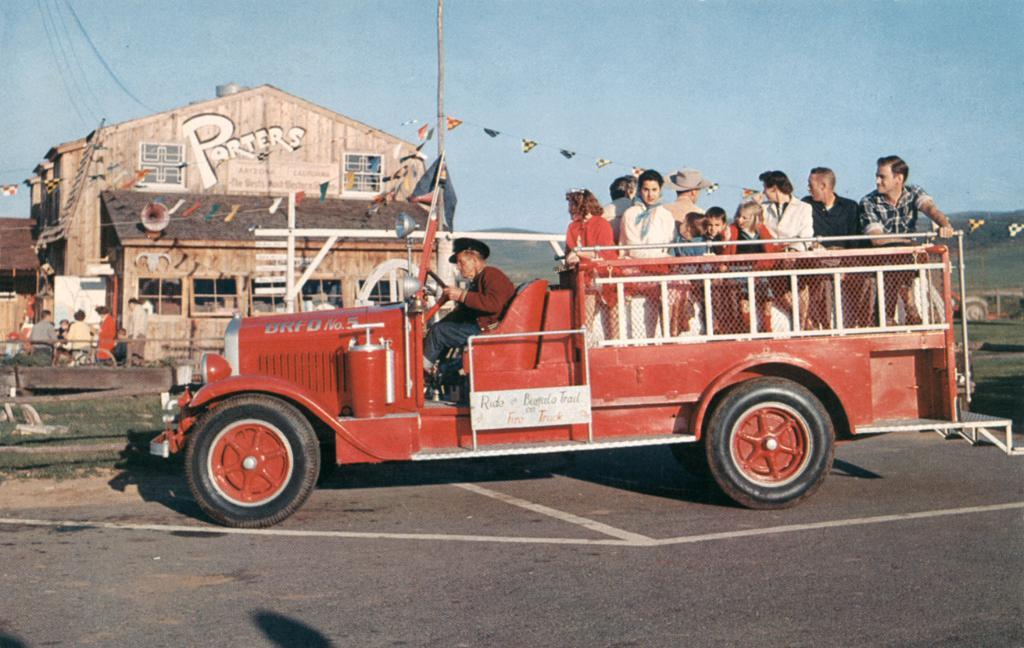What can be seen in the background of the image? The sky is visible in the background of the image. What type of establishment is present in the image? There is a store in the image. What decorative items are present in the image? Paper flags are present in the image. What architectural feature is visible in the image? There are windows in the image. What type of natural environment is visible in the image? Grass is visible in the image. What type of vertical structure is present in the image? There is a pole in the image. Who is present in the image? People are present in the image. What type of pathway is visible in the image? There is a road in the image. What mode of transportation is present in the image? There are people on a vehicle in the image. What type of vessel is present in the image? There is no vessel present in the image. What type of structure is being copied in the image? There is no structure being copied in the image. 